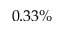Convert formula to latex. <formula><loc_0><loc_0><loc_500><loc_500>0 . 3 3 \%</formula> 